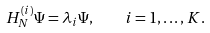Convert formula to latex. <formula><loc_0><loc_0><loc_500><loc_500>H _ { N } ^ { ( i ) } \Psi = \lambda _ { i } \Psi , \quad i = 1 , \dots , K .</formula> 